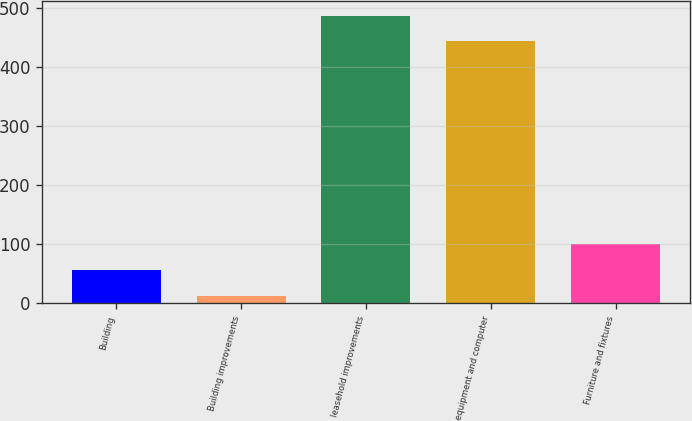<chart> <loc_0><loc_0><loc_500><loc_500><bar_chart><fcel>Building<fcel>Building improvements<fcel>leasehold improvements<fcel>equipment and computer<fcel>Furniture and fixtures<nl><fcel>56.9<fcel>13<fcel>486.9<fcel>443<fcel>100.8<nl></chart> 